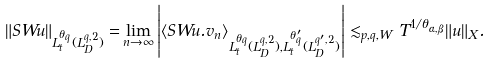<formula> <loc_0><loc_0><loc_500><loc_500>\| S W u \| _ { L _ { t } ^ { \theta _ { q } } ( L ^ { q , 2 } _ { D } ) } = & \lim _ { n \rightarrow \infty } \left | \left < S W u . v _ { n } \right > _ { L _ { t } ^ { \theta _ { q } } ( L ^ { q , 2 } _ { D } ) , L _ { t } ^ { \theta _ { q } ^ { \prime } } ( L ^ { q ^ { \prime } , 2 } _ { D } ) } \right | \lesssim _ { p , q , W } T ^ { 1 / \theta _ { \alpha , \beta } } \| u \| _ { X } .</formula> 